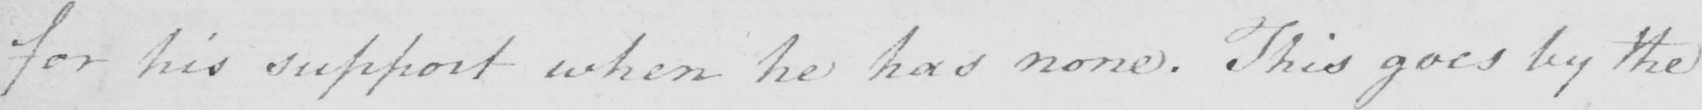What is written in this line of handwriting? for his support when he has none . This goes by the 